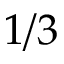Convert formula to latex. <formula><loc_0><loc_0><loc_500><loc_500>1 / 3</formula> 